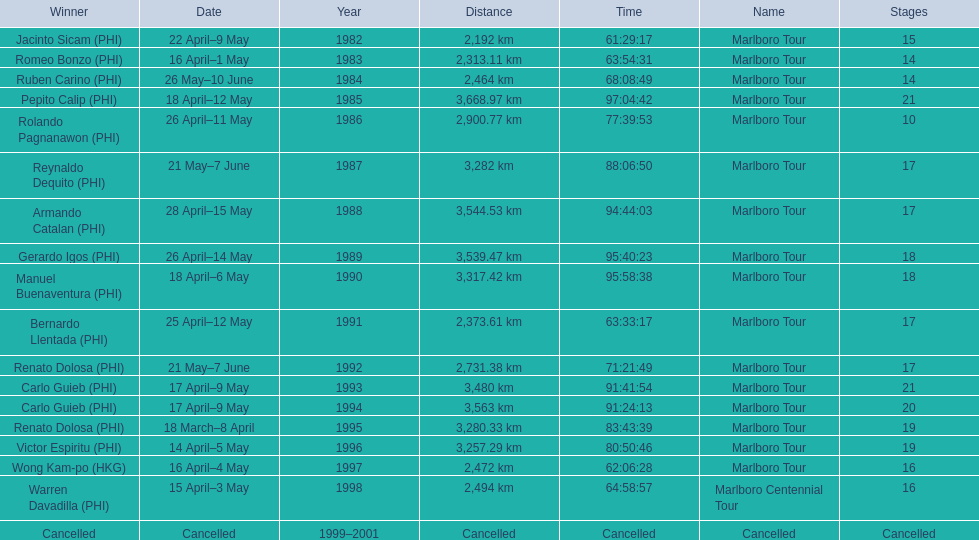How far did the marlboro tour travel each year? 2,192 km, 2,313.11 km, 2,464 km, 3,668.97 km, 2,900.77 km, 3,282 km, 3,544.53 km, 3,539.47 km, 3,317.42 km, 2,373.61 km, 2,731.38 km, 3,480 km, 3,563 km, 3,280.33 km, 3,257.29 km, 2,472 km, 2,494 km, Cancelled. In what year did they travel the furthest? 1985. How far did they travel that year? 3,668.97 km. 